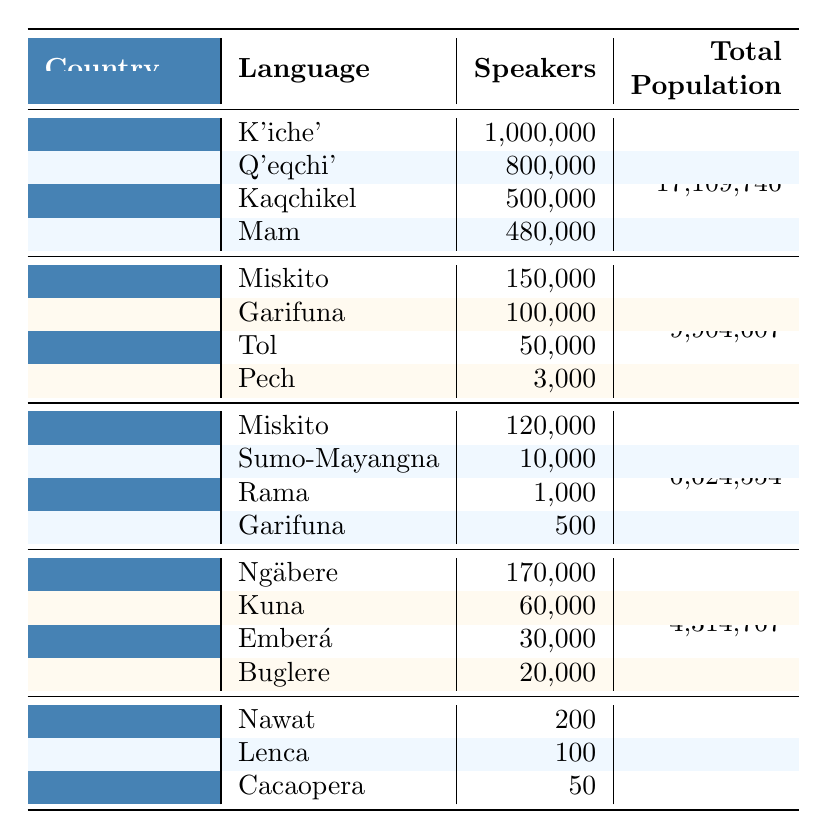What is the most spoken indigenous language in Guatemala? K'iche' has the highest number of speakers listed for Guatemala, with 1,000,000 speakers.
Answer: K'iche' How many indigenous languages are spoken in Honduras? The table lists four indigenous languages in Honduras: Miskito, Garifuna, Tol, and Pech.
Answer: Four What is the total population of Nicaragua? According to the table, the total population of Nicaragua is 6,624,554.
Answer: 6,624,554 Which country has the least number of speakers of indigenous languages? El Salvador has the least number of speakers with a total of 350 speakers (200 Nawat + 100 Lenca + 50 Cacaopera).
Answer: El Salvador What is the total number of indigenous language speakers in Panama? The speakers in Panama are Ngäbere (170,000) + Kuna (60,000) + Emberá (30,000) + Buglere (20,000), totaling 280,000 speakers.
Answer: 280,000 Is Miskito spoken more in Honduras than in Nicaragua? Miskito has 150,000 speakers in Honduras and 120,000 in Nicaragua, so Miskito is more spoken in Honduras.
Answer: Yes How does the population percentage of indigenous speakers compare in Guatemala versus El Salvador? In Guatemala, about 1,980,000 speakers of indigenous languages exist out of a total population of 17,109,746, which is approximately 11.56%. In El Salvador, there are 350 speakers out of a population of 6,486,205, which is about 0.0054%.
Answer: Guatemala has a higher percentage What is the combined number of speakers of the indigenous languages in Nicaragua? The total speakers in Nicaragua are calculated as 120,000 (Miskito) + 10,000 (Sumo-Mayangna) + 1,000 (Rama) + 500 (Garifuna) = 131,500 speakers.
Answer: 131,500 Which country has the highest total population? Guatemala has the highest total population listed in the table, with 17,109,746 people.
Answer: Guatemala Are there any languages listed for El Salvador with more than 300 speakers? The table lists Nawat (200), Lenca (100), and Cacaopera (50) for El Salvador, which are all below 300 speakers.
Answer: No 